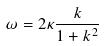<formula> <loc_0><loc_0><loc_500><loc_500>\omega = 2 \kappa \frac { k } { 1 + k ^ { 2 } }</formula> 